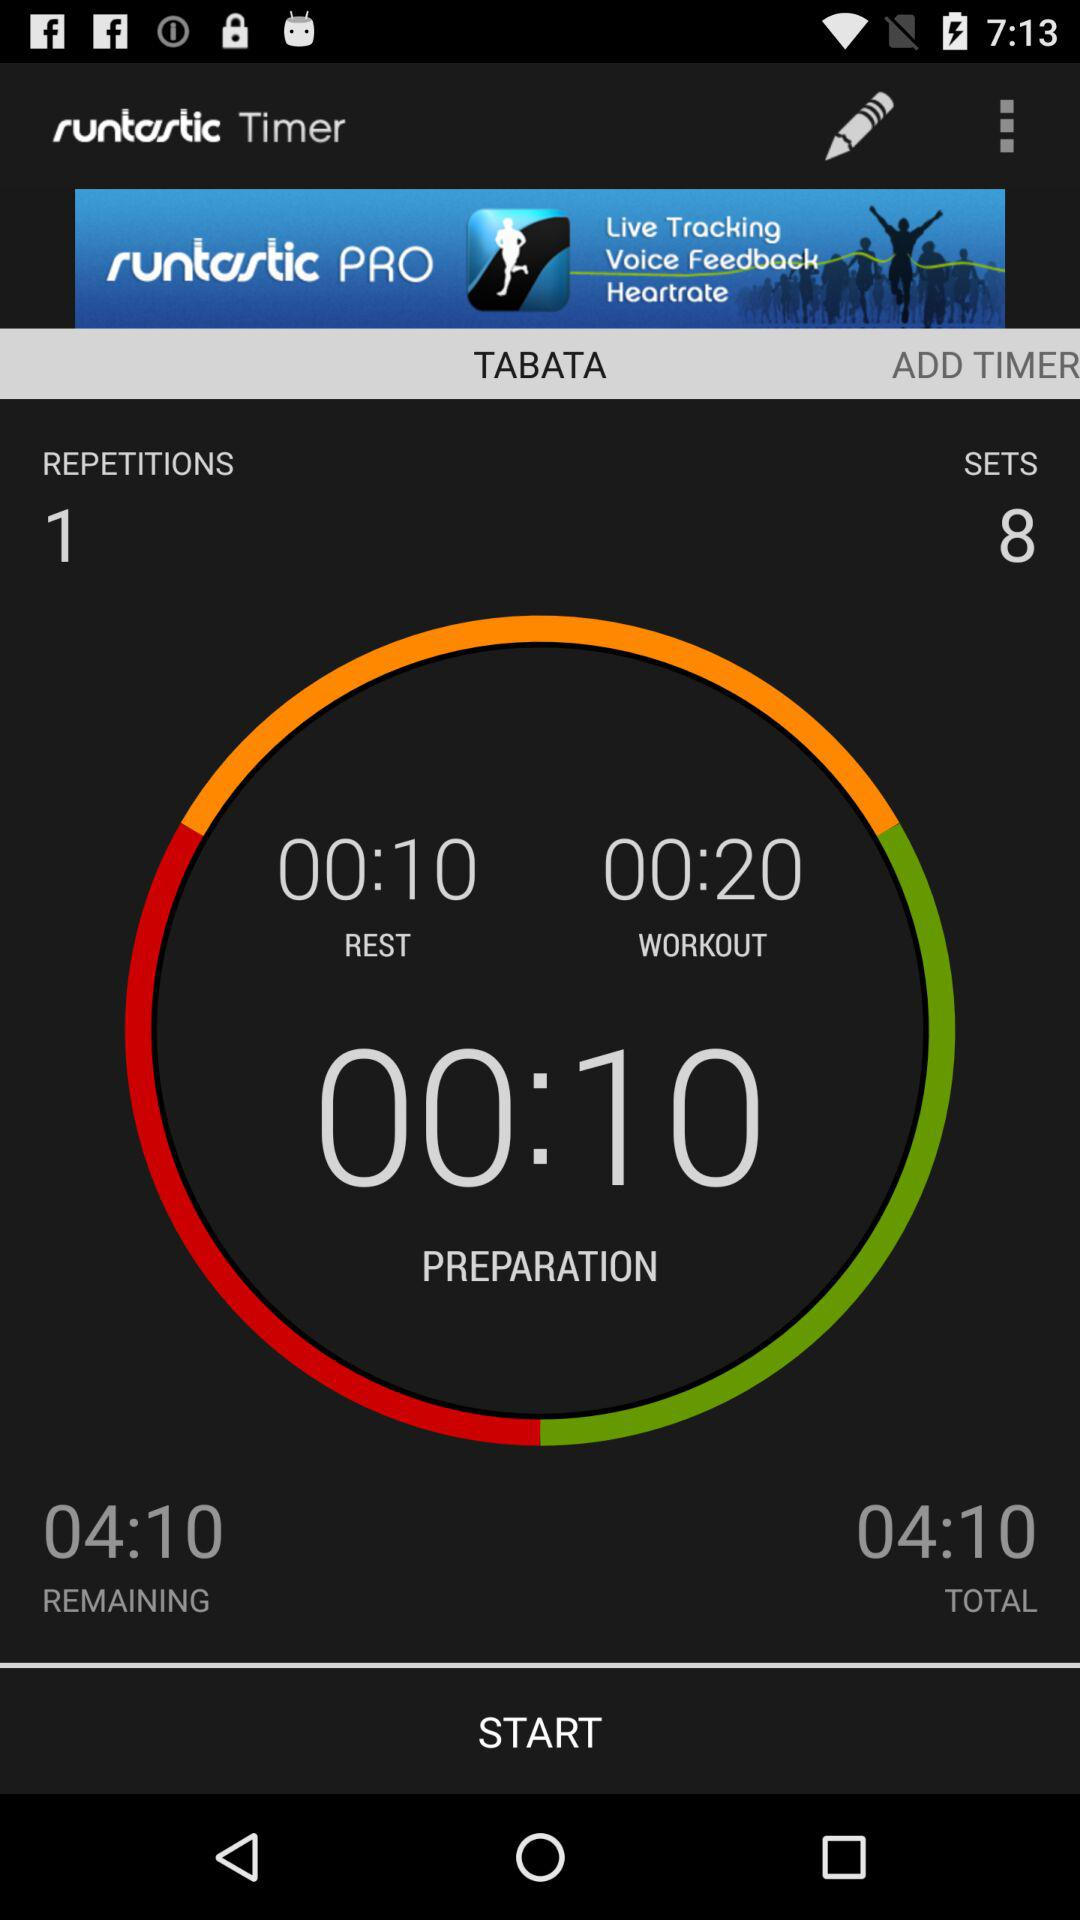How many sets in total are there? There are 8 sets. 